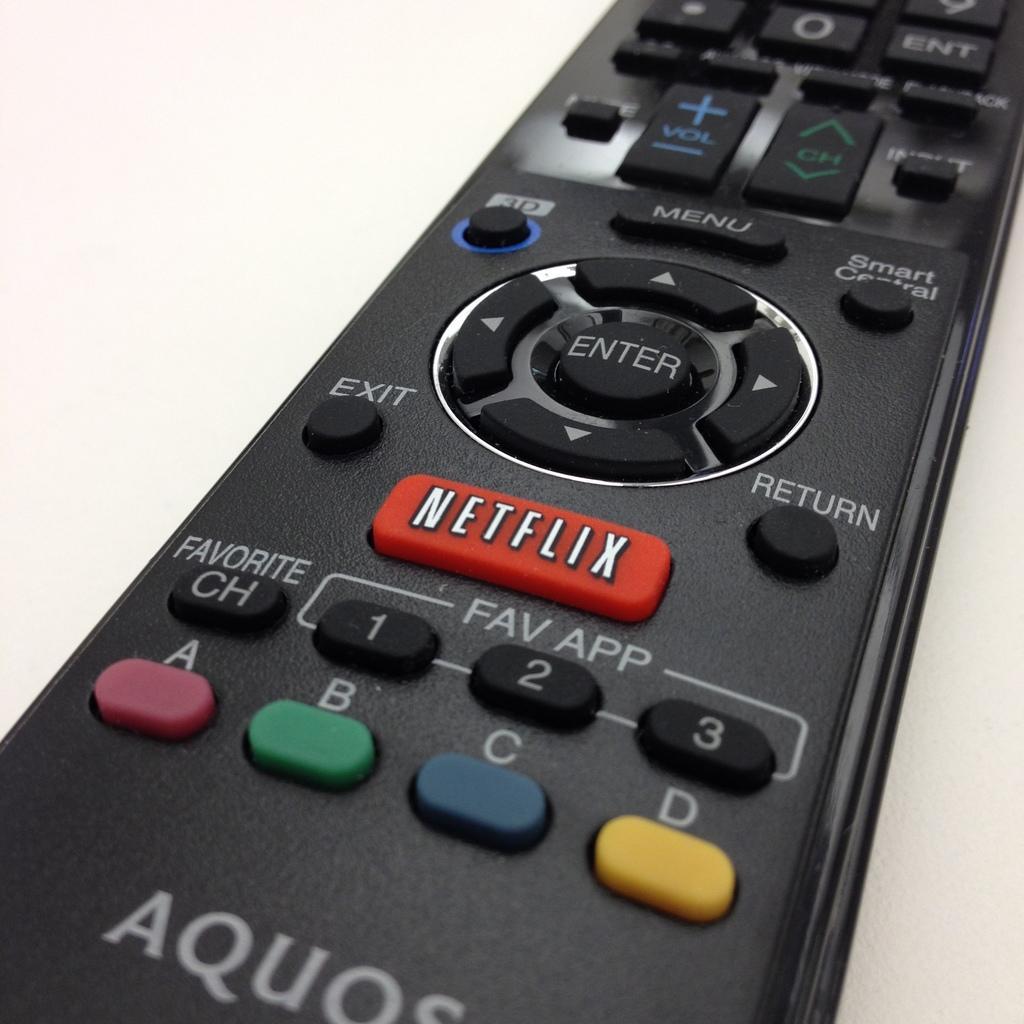Please provide a concise description of this image. In this picture we can see a remote on the surface. 